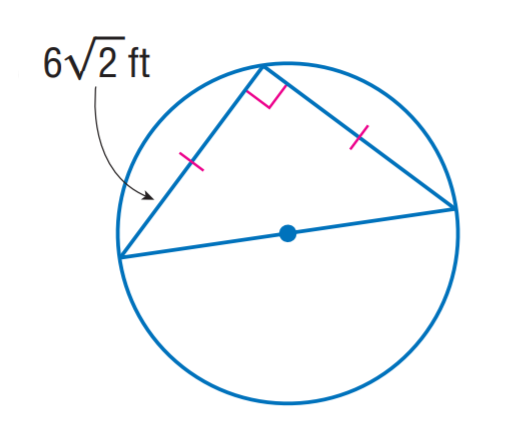Question: The triangle is inscribed into the circle. Find the exact circumference of the circle.
Choices:
A. 6 \pi
B. 6 \sqrt 2 \pi
C. 12 \pi
D. 12 \sqrt 2 \pi
Answer with the letter. Answer: C 